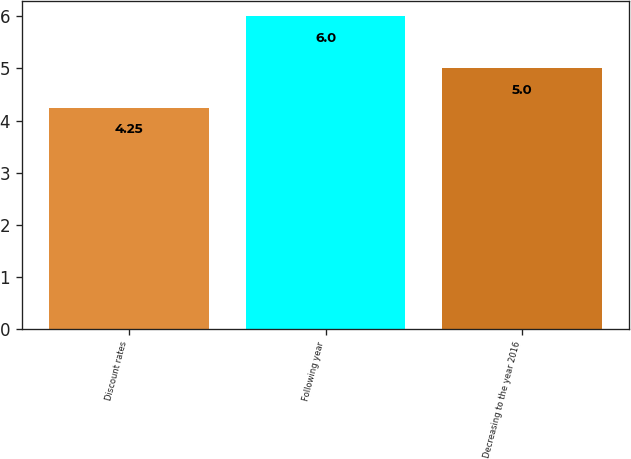Convert chart. <chart><loc_0><loc_0><loc_500><loc_500><bar_chart><fcel>Discount rates<fcel>Following year<fcel>Decreasing to the year 2016<nl><fcel>4.25<fcel>6<fcel>5<nl></chart> 